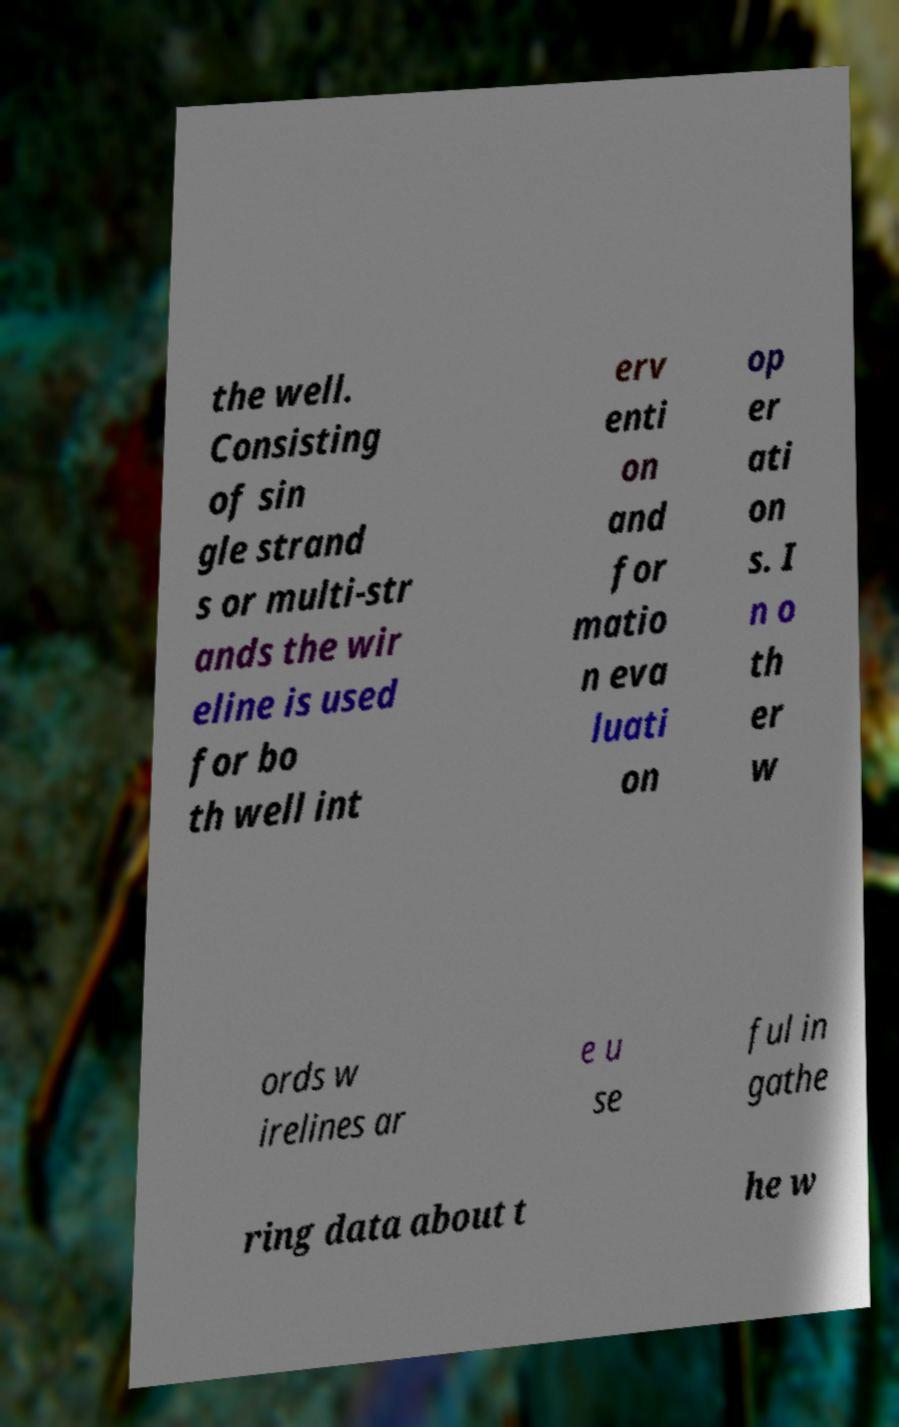Please read and relay the text visible in this image. What does it say? the well. Consisting of sin gle strand s or multi-str ands the wir eline is used for bo th well int erv enti on and for matio n eva luati on op er ati on s. I n o th er w ords w irelines ar e u se ful in gathe ring data about t he w 